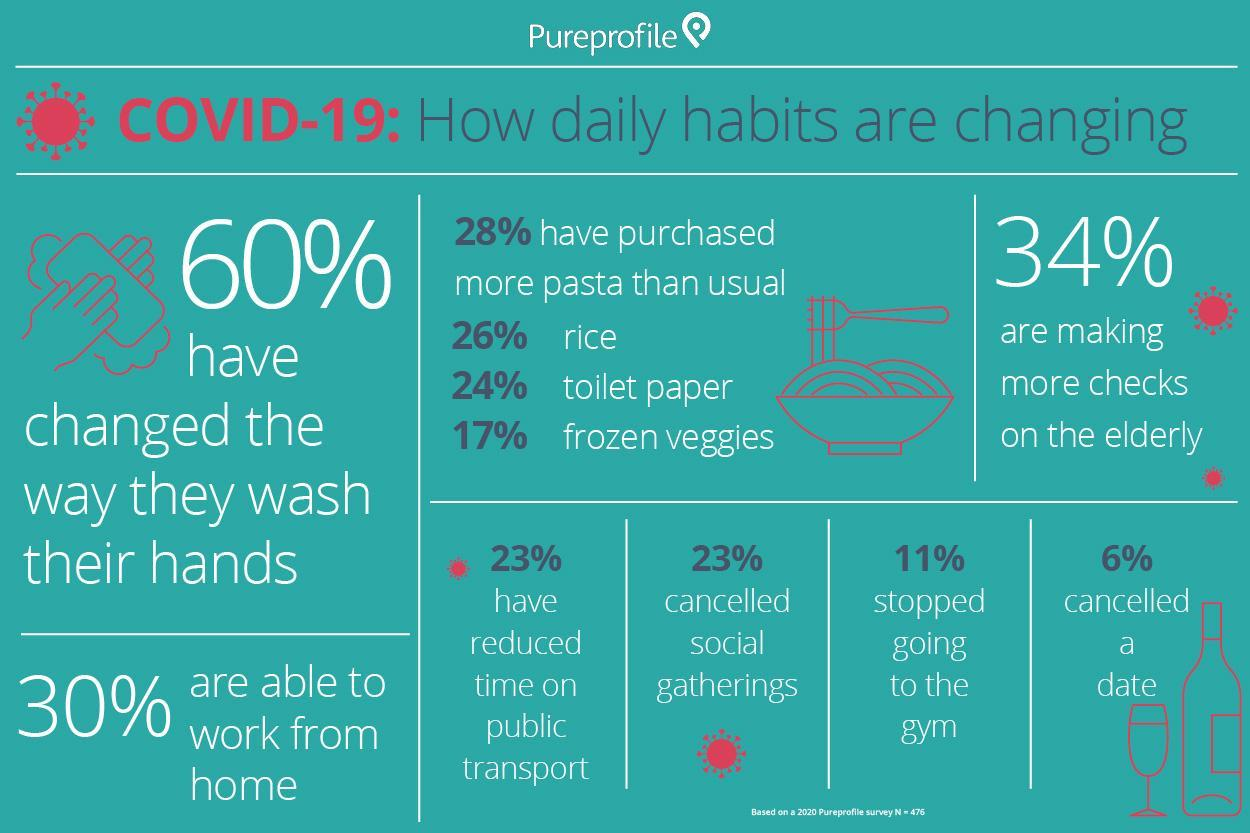What percentage of people are working remotely?
Answer the question with a short phrase. 30% What percentage of people cancelled social gatherings or reduced their time on public transport? 23% what food item has been bought more than usual by majority of people other than pasta? rice what food item has been bought more than usual by majority of people? pasta 